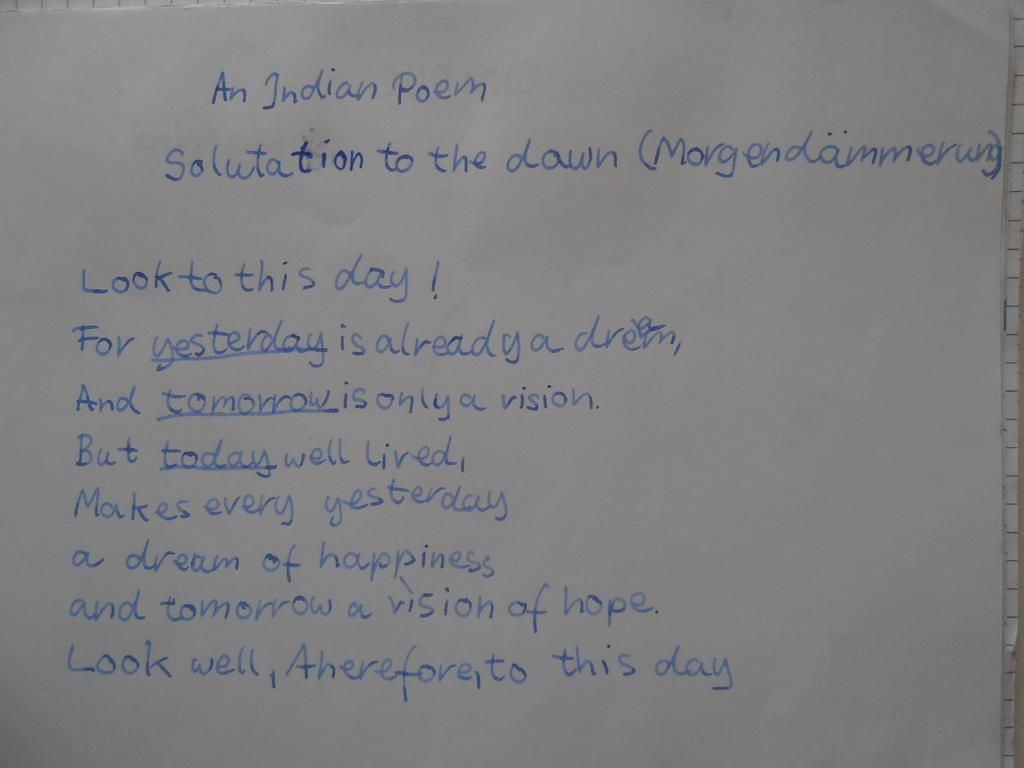<image>
Share a concise interpretation of the image provided. A sheet of paper with the heading An Indian Poem in blue. 